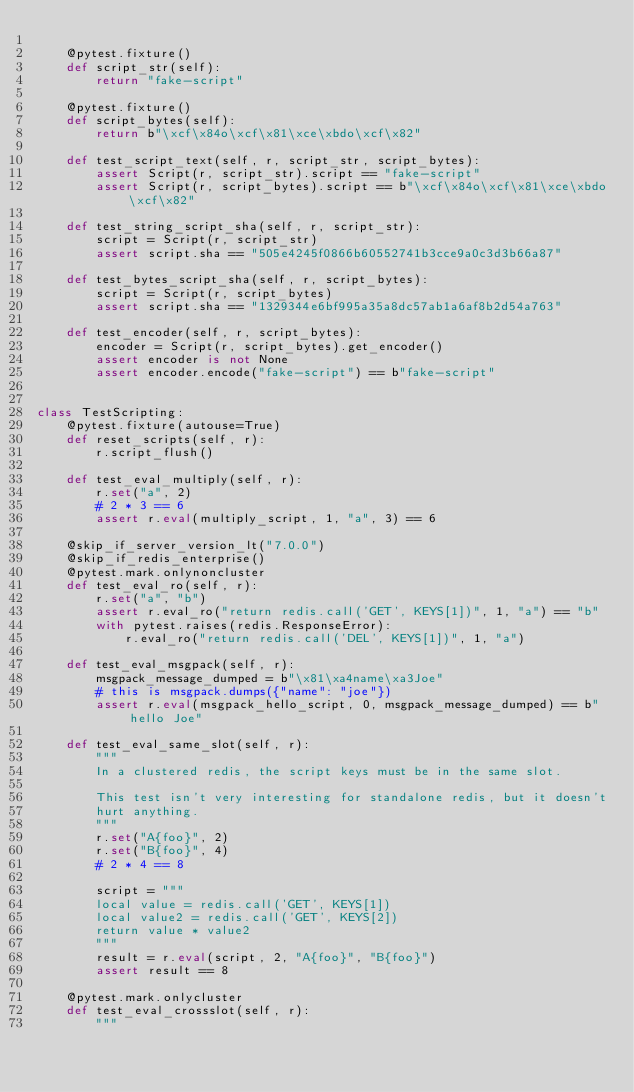<code> <loc_0><loc_0><loc_500><loc_500><_Python_>
    @pytest.fixture()
    def script_str(self):
        return "fake-script"

    @pytest.fixture()
    def script_bytes(self):
        return b"\xcf\x84o\xcf\x81\xce\xbdo\xcf\x82"

    def test_script_text(self, r, script_str, script_bytes):
        assert Script(r, script_str).script == "fake-script"
        assert Script(r, script_bytes).script == b"\xcf\x84o\xcf\x81\xce\xbdo\xcf\x82"

    def test_string_script_sha(self, r, script_str):
        script = Script(r, script_str)
        assert script.sha == "505e4245f0866b60552741b3cce9a0c3d3b66a87"

    def test_bytes_script_sha(self, r, script_bytes):
        script = Script(r, script_bytes)
        assert script.sha == "1329344e6bf995a35a8dc57ab1a6af8b2d54a763"

    def test_encoder(self, r, script_bytes):
        encoder = Script(r, script_bytes).get_encoder()
        assert encoder is not None
        assert encoder.encode("fake-script") == b"fake-script"


class TestScripting:
    @pytest.fixture(autouse=True)
    def reset_scripts(self, r):
        r.script_flush()

    def test_eval_multiply(self, r):
        r.set("a", 2)
        # 2 * 3 == 6
        assert r.eval(multiply_script, 1, "a", 3) == 6

    @skip_if_server_version_lt("7.0.0")
    @skip_if_redis_enterprise()
    @pytest.mark.onlynoncluster
    def test_eval_ro(self, r):
        r.set("a", "b")
        assert r.eval_ro("return redis.call('GET', KEYS[1])", 1, "a") == "b"
        with pytest.raises(redis.ResponseError):
            r.eval_ro("return redis.call('DEL', KEYS[1])", 1, "a")

    def test_eval_msgpack(self, r):
        msgpack_message_dumped = b"\x81\xa4name\xa3Joe"
        # this is msgpack.dumps({"name": "joe"})
        assert r.eval(msgpack_hello_script, 0, msgpack_message_dumped) == b"hello Joe"

    def test_eval_same_slot(self, r):
        """
        In a clustered redis, the script keys must be in the same slot.

        This test isn't very interesting for standalone redis, but it doesn't
        hurt anything.
        """
        r.set("A{foo}", 2)
        r.set("B{foo}", 4)
        # 2 * 4 == 8

        script = """
        local value = redis.call('GET', KEYS[1])
        local value2 = redis.call('GET', KEYS[2])
        return value * value2
        """
        result = r.eval(script, 2, "A{foo}", "B{foo}")
        assert result == 8

    @pytest.mark.onlycluster
    def test_eval_crossslot(self, r):
        """</code> 